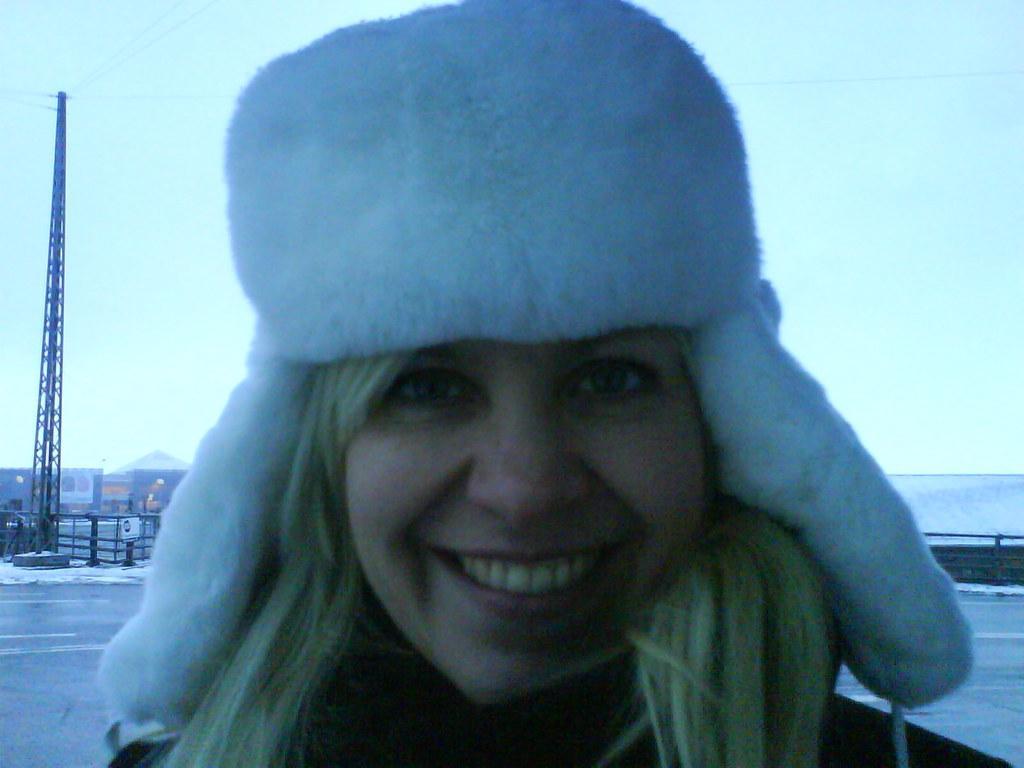Describe this image in one or two sentences. In this image there is a girl who is smiling. She is wearing the white cap. In the background there is a tower to which there are wires. There are buildings in the background. Beside the tower there is a fence. On the right side there is a wall in the background. 